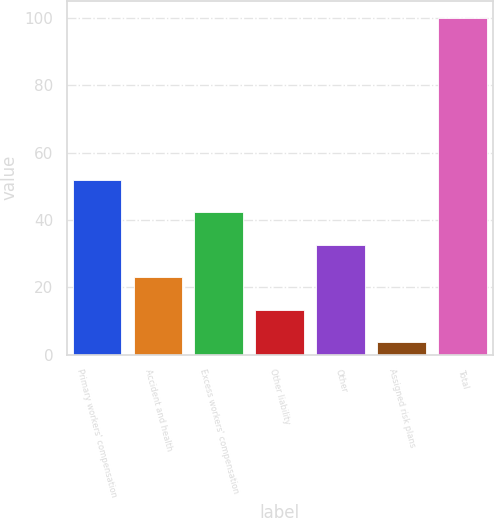Convert chart to OTSL. <chart><loc_0><loc_0><loc_500><loc_500><bar_chart><fcel>Primary workers' compensation<fcel>Accident and health<fcel>Excess workers' compensation<fcel>Other liability<fcel>Other<fcel>Assigned risk plans<fcel>Total<nl><fcel>51.85<fcel>22.96<fcel>42.22<fcel>13.33<fcel>32.59<fcel>3.7<fcel>100<nl></chart> 